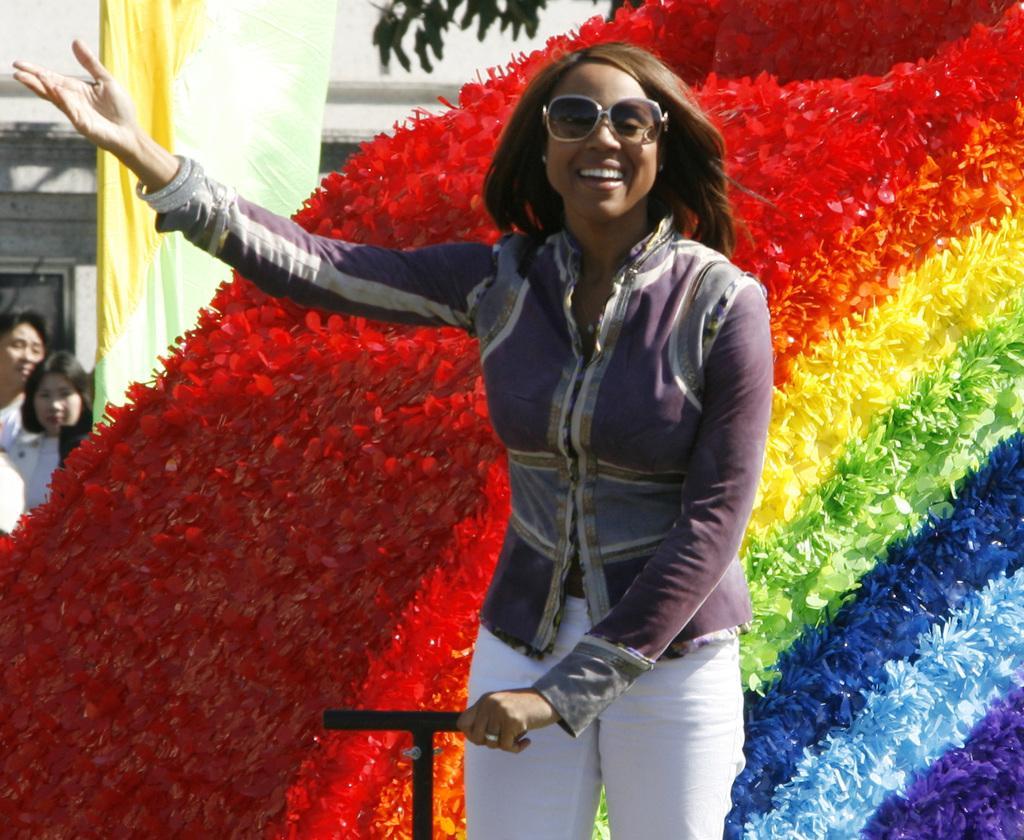Could you give a brief overview of what you see in this image? Here we can see a woman. She is smiling and she has goggles. In the background we can see an object, two women, banner, and a wall. 